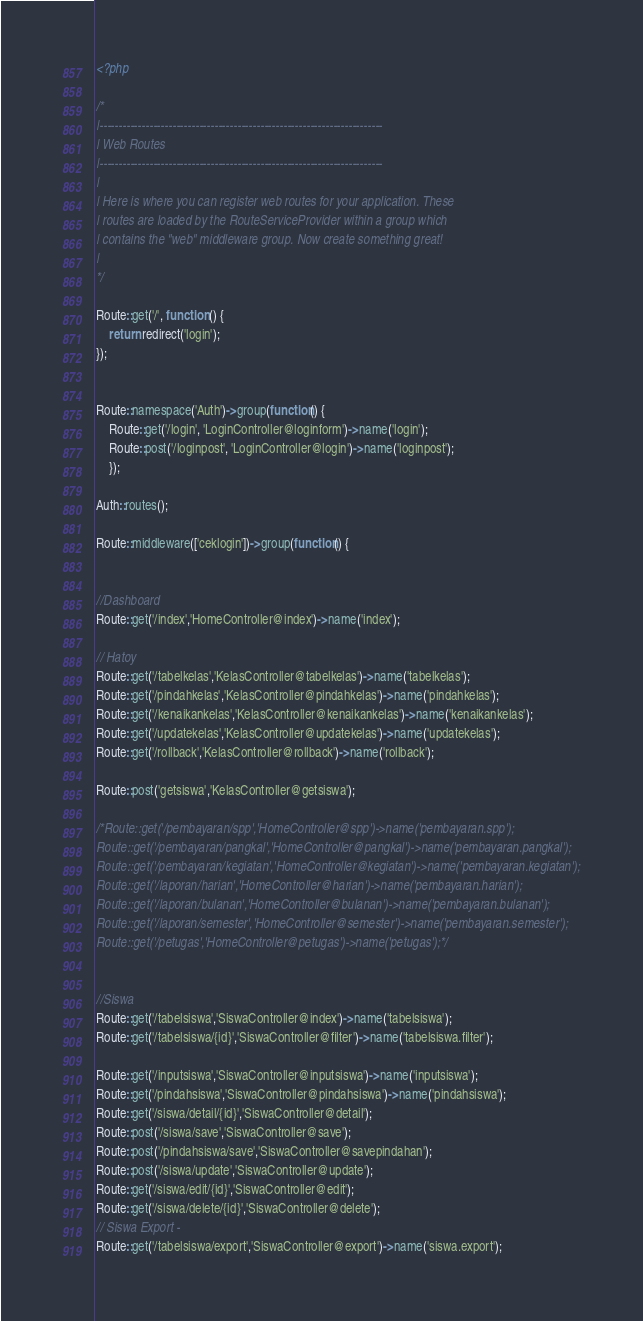Convert code to text. <code><loc_0><loc_0><loc_500><loc_500><_PHP_><?php

/*
|--------------------------------------------------------------------------
| Web Routes
|--------------------------------------------------------------------------
|
| Here is where you can register web routes for your application. These
| routes are loaded by the RouteServiceProvider within a group which
| contains the "web" middleware group. Now create something great!
|
*/

Route::get('/', function () {
    return redirect('login');
});


Route::namespace('Auth')->group(function() {
    Route::get('/login', 'LoginController@loginform')->name('login');
    Route::post('/loginpost', 'LoginController@login')->name('loginpost');
    }); 

Auth::routes();

Route::middleware(['ceklogin'])->group(function() {


//Dashboard
Route::get('/index','HomeController@index')->name('index');

// Hatoy
Route::get('/tabelkelas','KelasController@tabelkelas')->name('tabelkelas');
Route::get('/pindahkelas','KelasController@pindahkelas')->name('pindahkelas');
Route::get('/kenaikankelas','KelasController@kenaikankelas')->name('kenaikankelas');
Route::get('/updatekelas','KelasController@updatekelas')->name('updatekelas');
Route::get('/rollback','KelasController@rollback')->name('rollback');

Route::post('getsiswa','KelasController@getsiswa');

/*Route::get('/pembayaran/spp','HomeController@spp')->name('pembayaran.spp');
Route::get('/pembayaran/pangkal','HomeController@pangkal')->name('pembayaran.pangkal');
Route::get('/pembayaran/kegiatan','HomeController@kegiatan')->name('pembayaran.kegiatan');
Route::get('/laporan/harian','HomeController@harian')->name('pembayaran.harian');
Route::get('/laporan/bulanan','HomeController@bulanan')->name('pembayaran.bulanan');
Route::get('/laporan/semester','HomeController@semester')->name('pembayaran.semester');
Route::get('/petugas','HomeController@petugas')->name('petugas');*/


//Siswa
Route::get('/tabelsiswa','SiswaController@index')->name('tabelsiswa');
Route::get('/tabelsiswa/{id}','SiswaController@filter')->name('tabelsiswa.filter');

Route::get('/inputsiswa','SiswaController@inputsiswa')->name('inputsiswa');
Route::get('/pindahsiswa','SiswaController@pindahsiswa')->name('pindahsiswa');
Route::get('/siswa/detail/{id}','SiswaController@detail');
Route::post('/siswa/save','SiswaController@save');
Route::post('/pindahsiswa/save','SiswaController@savepindahan');
Route::post('/siswa/update','SiswaController@update');
Route::get('/siswa/edit/{id}','SiswaController@edit');
Route::get('/siswa/delete/{id}','SiswaController@delete');
// Siswa Export - 
Route::get('/tabelsiswa/export','SiswaController@export')->name('siswa.export');</code> 